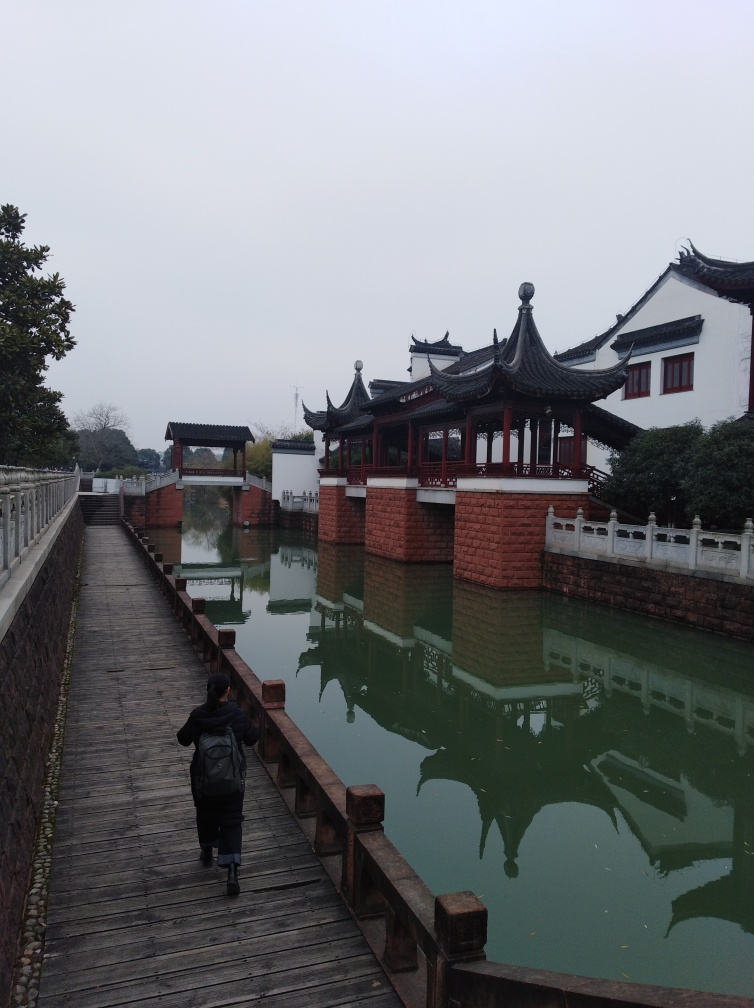What does the presence of a single person add to this scene? The lone individual walking on the wooden path adds a human element to the scene, creating a narrative and suggesting solitude or contemplation. Their presence invites viewers to reflect on their own thoughts, consider the serene environment, and perhaps imagine the sounds of footsteps on wood and water gently lapping against the brick retaining walls. What time of year do you think this image represents, and why? Judging by the absence of foliage on the trees and the person's attire, it suggests a cooler season, possibly late autumn or winter. The subdued color palette with the lack of vibrant flowers or green leaves implies that the image was not taken during the spring or summer months. 